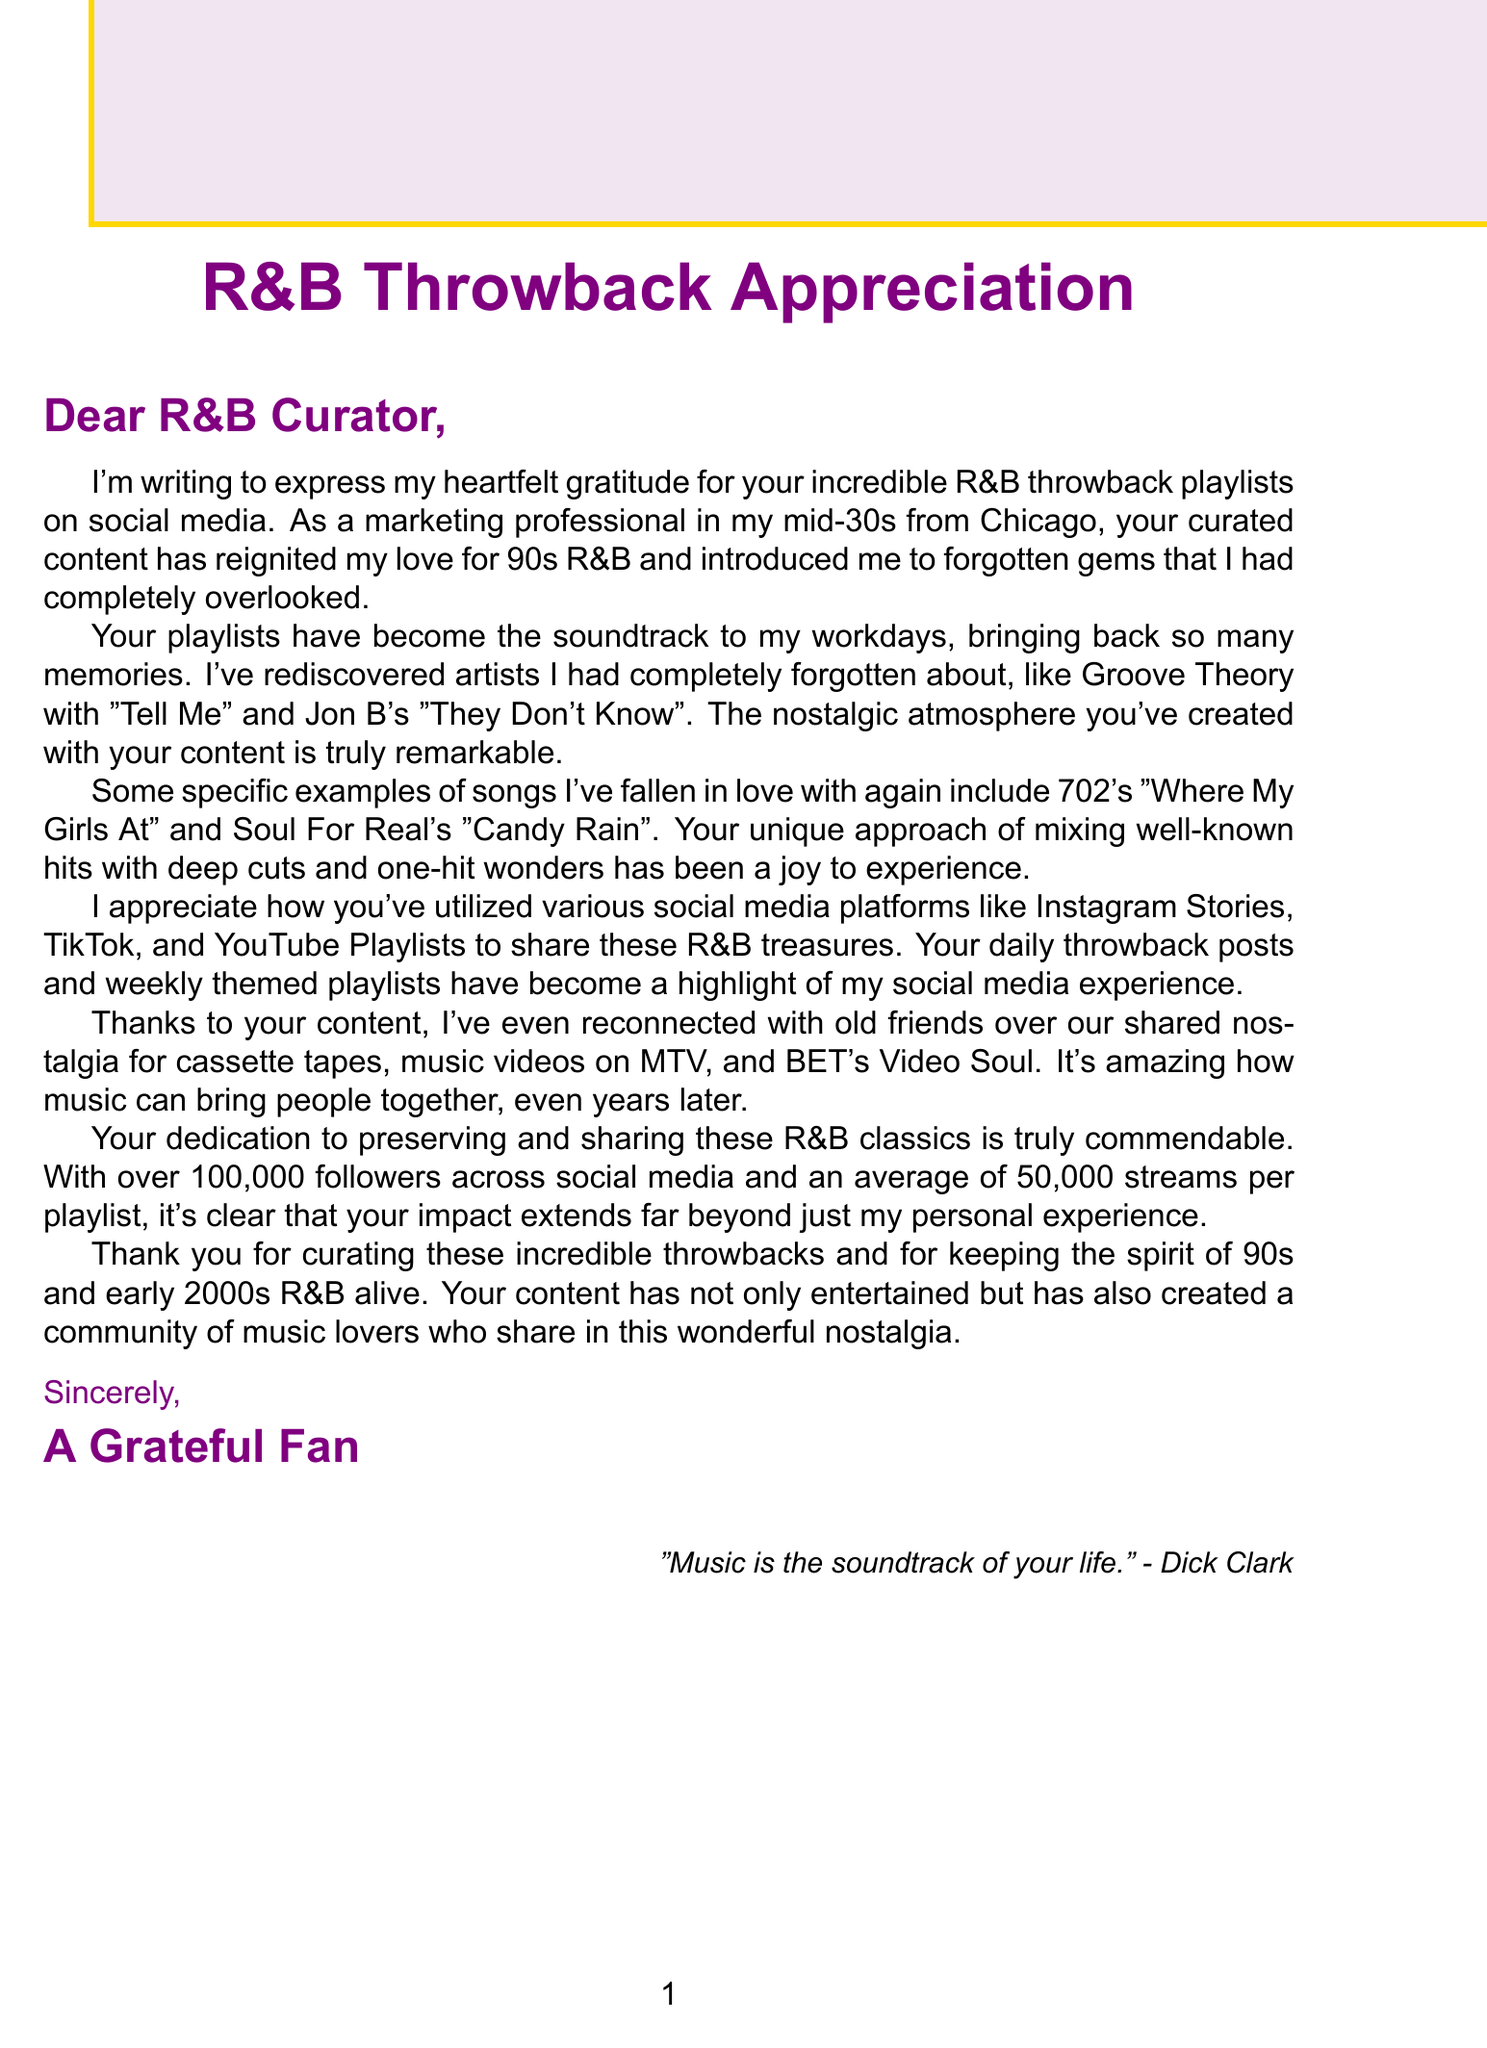What is the fan's occupation? The fan's occupation is stated in the document as "Marketing professional."
Answer: Marketing professional What city is the fan located in? The document specifies that the fan is from "Chicago, Illinois."
Answer: Chicago, Illinois Which song by Groove Theory is mentioned? The document points out that "Tell Me" by Groove Theory is one of the rediscovered songs.
Answer: Tell Me How many followers does the curator have across social media? The document indicates that the curator has "over 100,000 followers across social media."
Answer: Over 100,000 What is the average number of streams per playlist? The document states the average number of streams per playlist is "50,000."
Answer: 50,000 What nostalgic medium is referenced in the letter? The letter mentions "cassette tapes" as a nostalgic medium.
Answer: Cassette tapes Name one of the specific songs that the fan rediscovered. The document highlights "Candy Rain" by Soul For Real as a rediscovered song.
Answer: Candy Rain What effect have the playlists had on social connections? The letter describes that the playlists have helped the fan to "reconnect with old friends."
Answer: Reconnect with old friends What type of content frequency does the curator maintain? The document states that the curator posts "daily throwback posts and weekly themed playlists."
Answer: Daily throwback posts and weekly themed playlists 